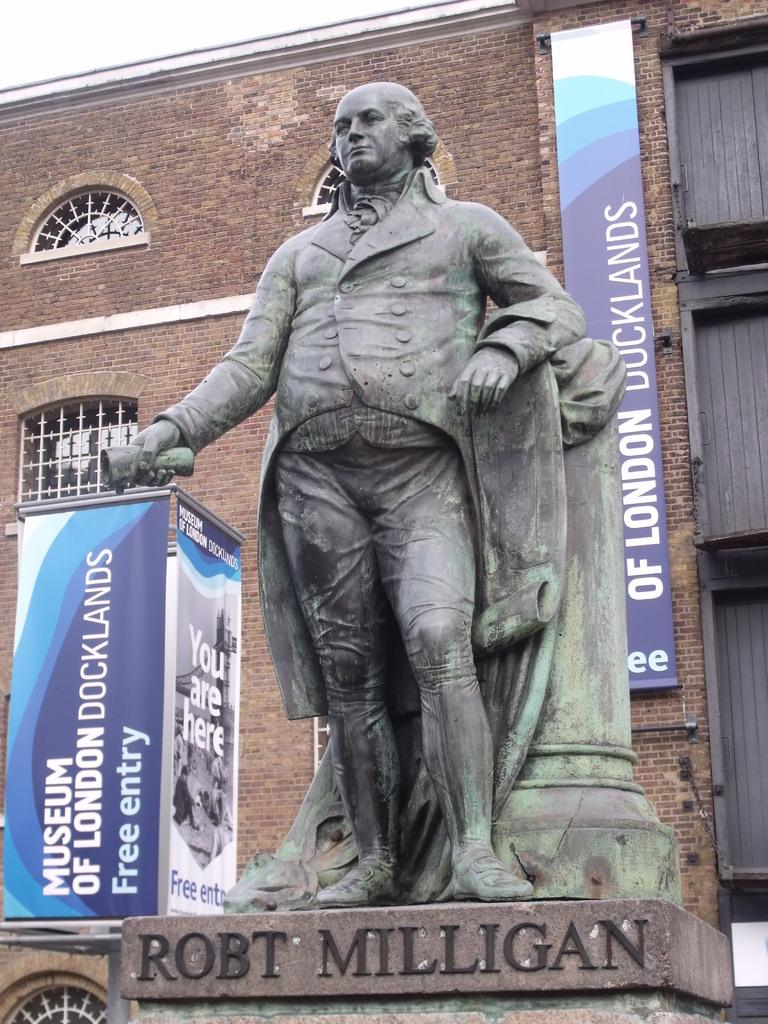What is the main subject in the image? There is a sculpture in the image. What type of structure is also visible in the image? There is a building with windows in the image. What additional elements can be seen in the image? There are banners in the image. What type of cabbage is being used to hold the banners in the image? There is no cabbage present in the image, and therefore it cannot be used to hold the banners. What rate is the sculpture spinning at in the image? The sculpture is not spinning in the image; it is stationary. 